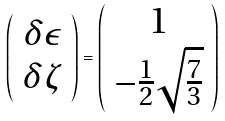<formula> <loc_0><loc_0><loc_500><loc_500>\left ( \begin{array} { c } \delta \epsilon \\ \delta \zeta \end{array} \right ) = \left ( \begin{array} { c } 1 \\ - \frac { 1 } { 2 } \sqrt { \frac { 7 } { 3 } } \end{array} \right )</formula> 